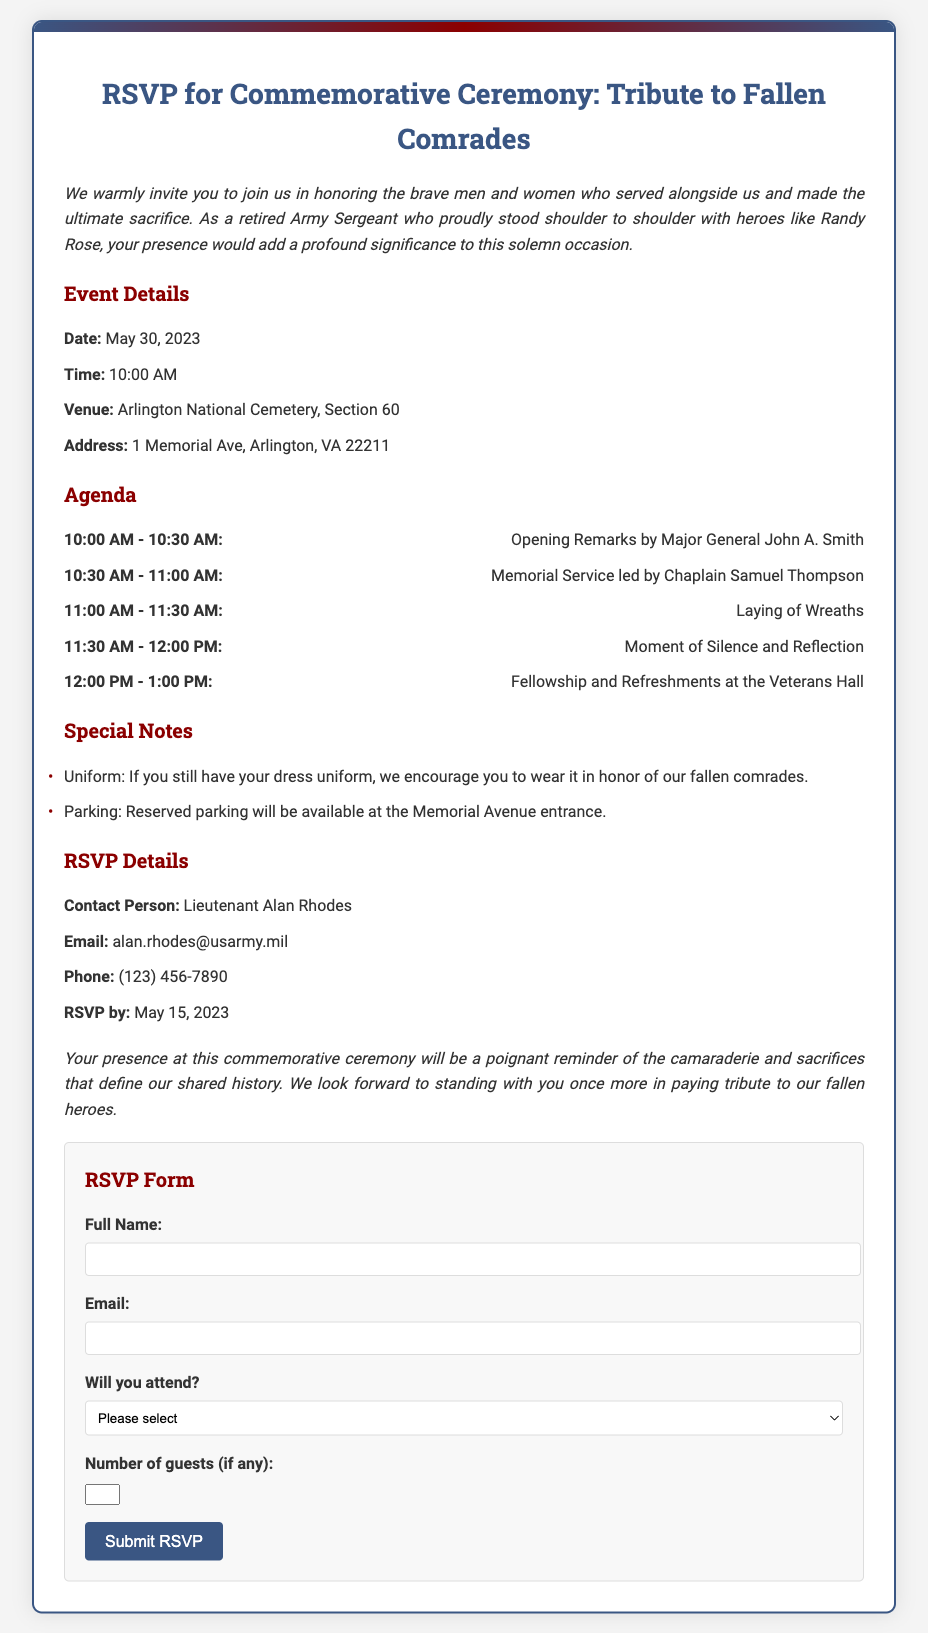what is the date of the ceremony? The date of the ceremony is specified in the event details section of the document.
Answer: May 30, 2023 who is the contact person for RSVP? The contact person for RSVP is mentioned in the RSVP details section of the document.
Answer: Lieutenant Alan Rhodes what time does the ceremony begin? The time at which the ceremony starts is found in the event details section of the document.
Answer: 10:00 AM where will the ceremony take place? The venue for the ceremony is listed in the event details section of the document.
Answer: Arlington National Cemetery, Section 60 how many guests can be added to the RSVP? The maximum number of guests that can be included is mentioned in the RSVP form section of the document.
Answer: 2 what special attire is suggested for the ceremony? The special attire recommendation is provided in the special notes section of the document.
Answer: Dress uniform who is leading the memorial service? The individual leading the memorial service is stated in the agenda section of the document.
Answer: Chaplain Samuel Thompson when is the RSVP deadline? The deadline for submitting the RSVP is detailed in the RSVP details section of the document.
Answer: May 15, 2023 what type of refreshments will be served? The type of refreshments to be served is implied in the agenda section of the document.
Answer: Fellowship and Refreshments 